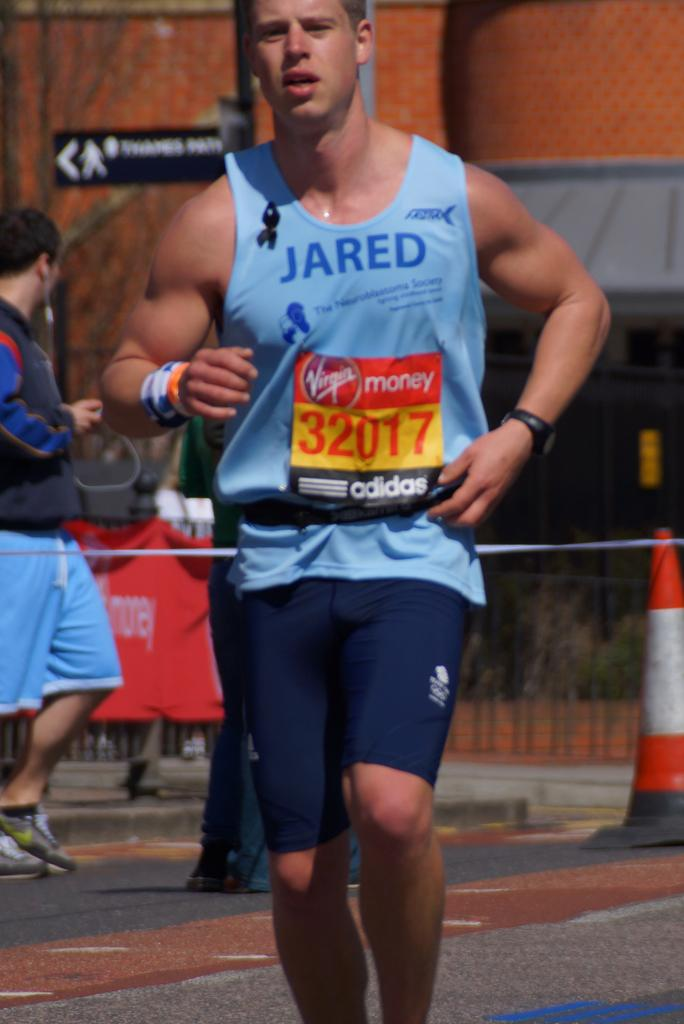What is the main subject in the foreground of the image? There is a person standing on the road in the foreground of the image. What can be seen in the background of the image? In the background, there is a traffic pole, a ribbon, a person standing, a sign board attached to a board attached to a pole, a fence, and a wall. Can you describe the pole in the background? There is a traffic pole in the background, which is a common feature in urban environments. What is attached to the pole in the background? There is a sign board attached to the pole in the background, which may contain information or directions. What type of glove is the person wearing in the image? There is no glove visible in the image; the person is not wearing any gloves. 